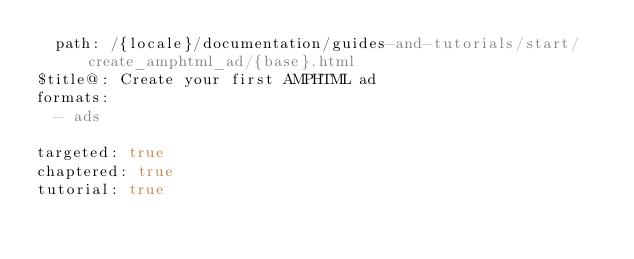<code> <loc_0><loc_0><loc_500><loc_500><_YAML_>  path: /{locale}/documentation/guides-and-tutorials/start/create_amphtml_ad/{base}.html
$title@: Create your first AMPHTML ad
formats:
  - ads

targeted: true
chaptered: true
tutorial: true
</code> 